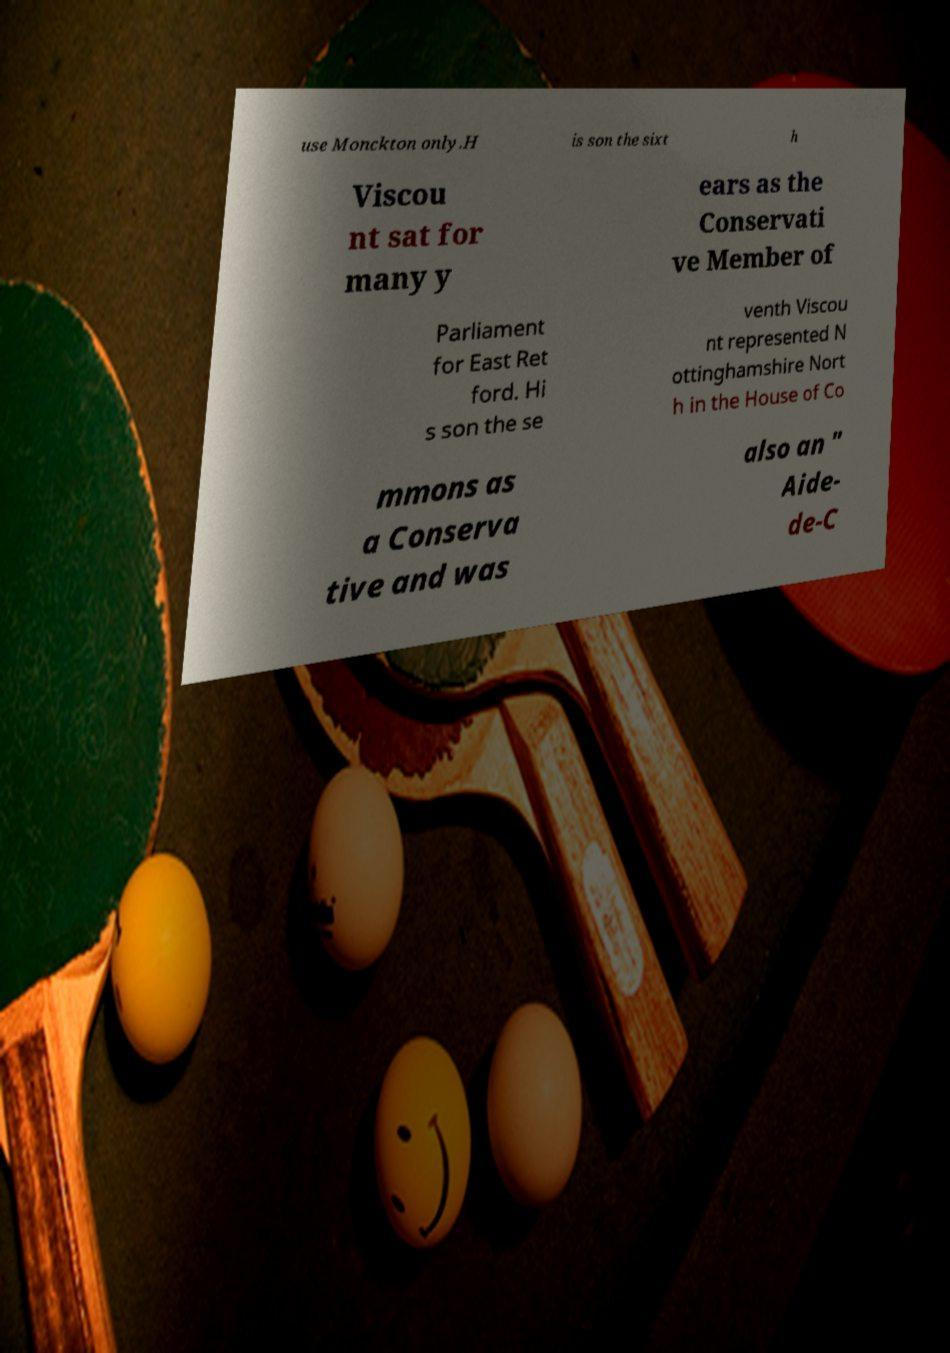Could you assist in decoding the text presented in this image and type it out clearly? use Monckton only.H is son the sixt h Viscou nt sat for many y ears as the Conservati ve Member of Parliament for East Ret ford. Hi s son the se venth Viscou nt represented N ottinghamshire Nort h in the House of Co mmons as a Conserva tive and was also an " Aide- de-C 